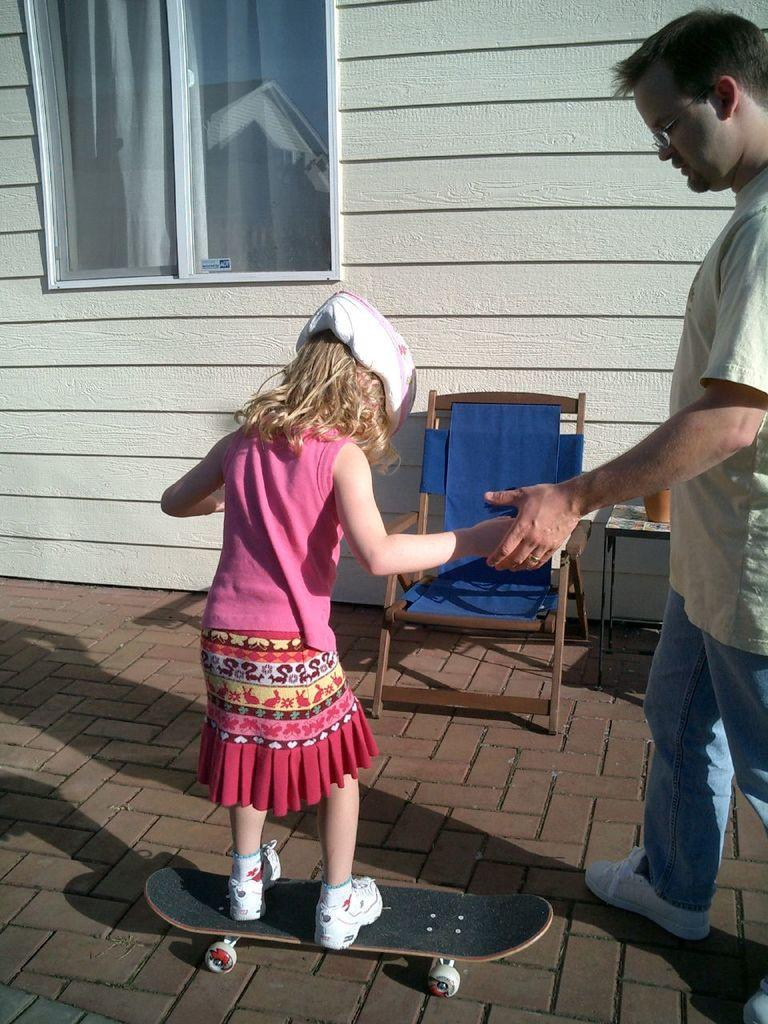Who is the main subject in the image? There is a girl in the image. What is the girl doing in the image? The girl is standing on a skateboard. Who is assisting the girl in the image? A man is holding the girl's hand. What safety precaution is the girl taking in the image? The girl is wearing a helmet. What can be seen in the background of the image? There is a building in the background of the image. How many horses are present in the image? There are no horses present in the image. What type of locket is the girl wearing in the image? The girl is not wearing a locket in the image. 